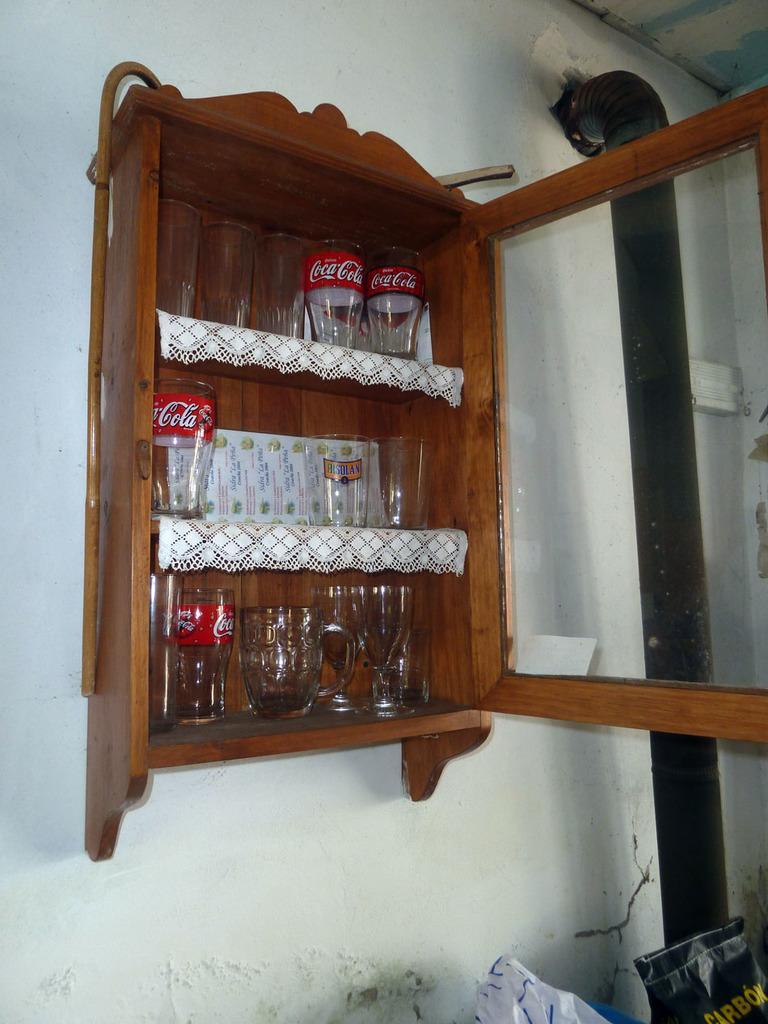Describe this image in one or two sentences. In this picture there is a small wooden almirah attached to the wall which has glasses placed in it and there is a pipe in the right corner. 